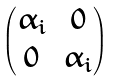<formula> <loc_0><loc_0><loc_500><loc_500>\begin{pmatrix} \alpha _ { i } & 0 \\ 0 & \alpha _ { i } \end{pmatrix}</formula> 